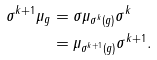Convert formula to latex. <formula><loc_0><loc_0><loc_500><loc_500>\sigma ^ { k + 1 } \mu _ { g } & = \sigma \mu _ { \sigma ^ { k } ( g ) } \sigma ^ { k } \\ & = \mu _ { \sigma ^ { k + 1 } ( g ) } \sigma ^ { k + 1 } .</formula> 